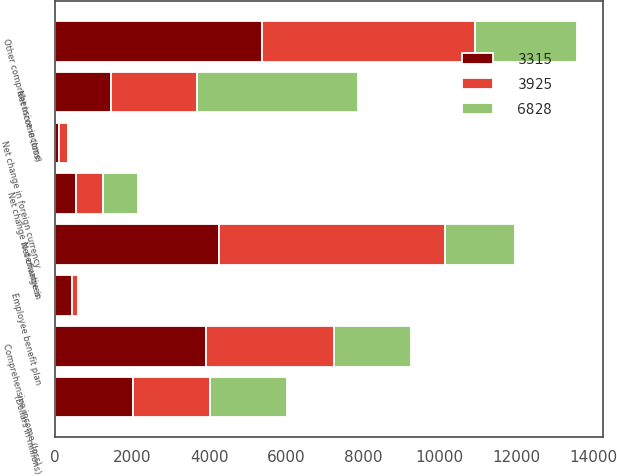Convert chart to OTSL. <chart><loc_0><loc_0><loc_500><loc_500><stacked_bar_chart><ecel><fcel>(Dollars in millions)<fcel>Net income (loss)<fcel>Net change in<fcel>Net change in derivatives<fcel>Employee benefit plan<fcel>Net change in foreign currency<fcel>Other comprehensive income<fcel>Comprehensive income (loss)<nl><fcel>6828<fcel>2012<fcel>4188<fcel>1802<fcel>916<fcel>65<fcel>13<fcel>2640<fcel>2010<nl><fcel>3315<fcel>2011<fcel>1446<fcel>4270<fcel>549<fcel>444<fcel>108<fcel>5371<fcel>3925<nl><fcel>3925<fcel>2010<fcel>2238<fcel>5872<fcel>701<fcel>145<fcel>237<fcel>5553<fcel>3315<nl></chart> 